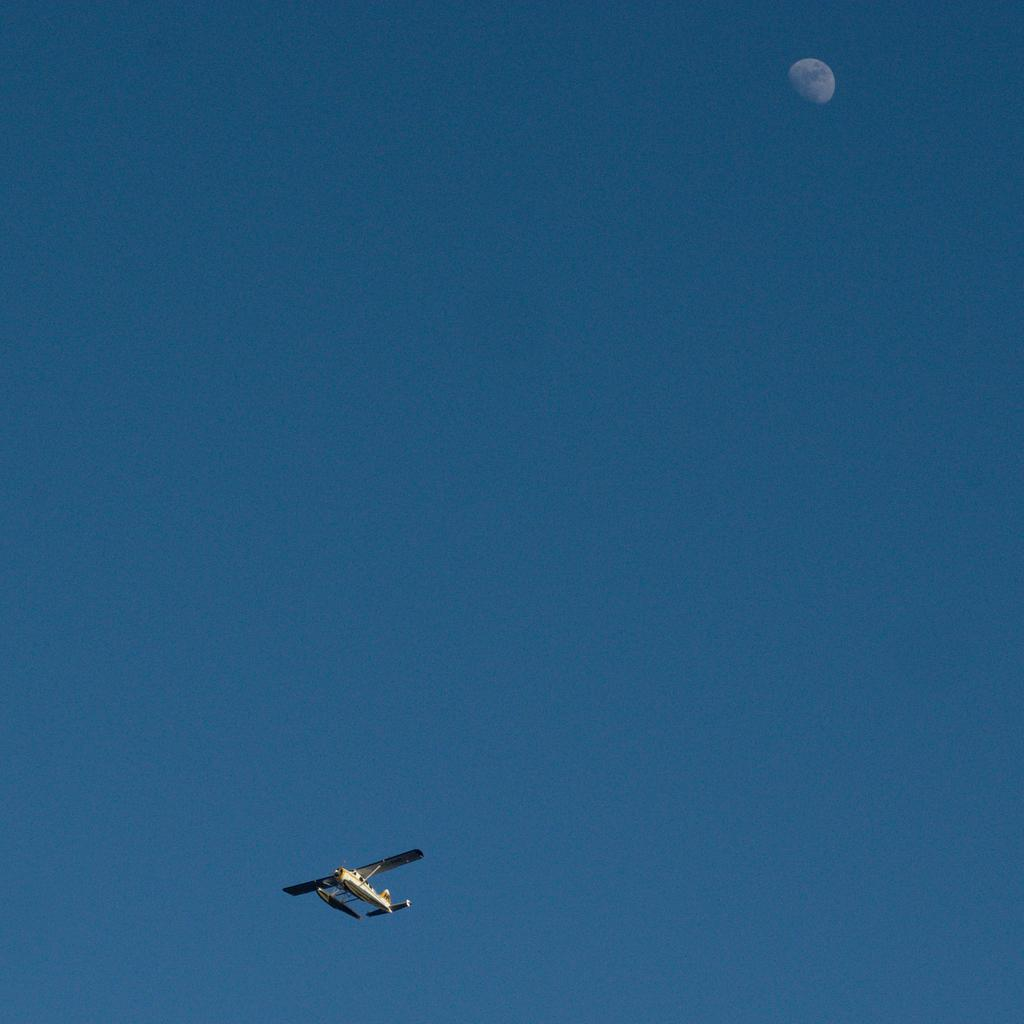What is the main subject of the image? The main subject of the image is an airplane. What is the airplane doing in the image? The airplane is flying in the sky. What celestial body can be seen in the sky in the image? The moon is visible in the sky. What type of sea creature can be seen smashing the airplane in the image? There is no sea creature present in the image, and the airplane is not being smashed. 